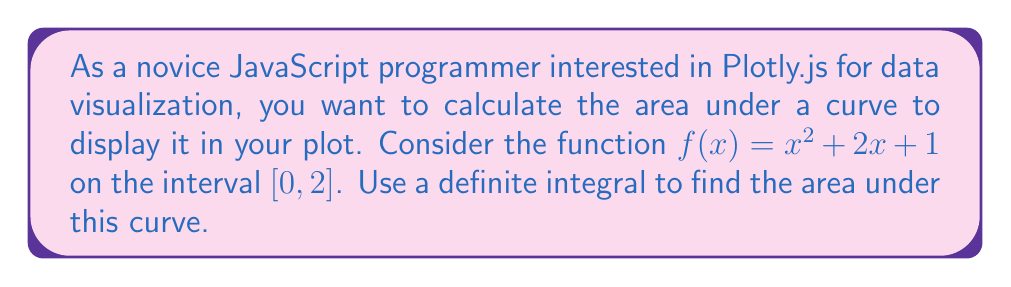Could you help me with this problem? To find the area under the curve of $f(x) = x^2 + 2x + 1$ from $x = 0$ to $x = 2$, we need to calculate the definite integral of this function over the given interval. Here's how to do it step by step:

1. Set up the definite integral:
   $$\int_0^2 (x^2 + 2x + 1) dx$$

2. Integrate the function:
   - For $x^2$: $\int x^2 dx = \frac{1}{3}x^3$
   - For $2x$: $\int 2x dx = x^2$
   - For $1$: $\int 1 dx = x$

   So, the indefinite integral is:
   $$\int (x^2 + 2x + 1) dx = \frac{1}{3}x^3 + x^2 + x + C$$

3. Apply the limits of integration:
   $$[\frac{1}{3}x^3 + x^2 + x]_0^2$$

4. Evaluate at the upper limit ($x = 2$):
   $$\frac{1}{3}(2^3) + 2^2 + 2 = \frac{8}{3} + 4 + 2 = \frac{8}{3} + \frac{12}{3} + \frac{6}{3} = \frac{26}{3}$$

5. Evaluate at the lower limit ($x = 0$):
   $$\frac{1}{3}(0^3) + 0^2 + 0 = 0$$

6. Subtract the lower limit result from the upper limit result:
   $$\frac{26}{3} - 0 = \frac{26}{3}$$

Therefore, the area under the curve of $f(x) = x^2 + 2x + 1$ from $x = 0$ to $x = 2$ is $\frac{26}{3}$ square units.

In JavaScript with Plotly.js, you could use this value to shade the area under the curve in your visualization.
Answer: $\frac{26}{3}$ square units 